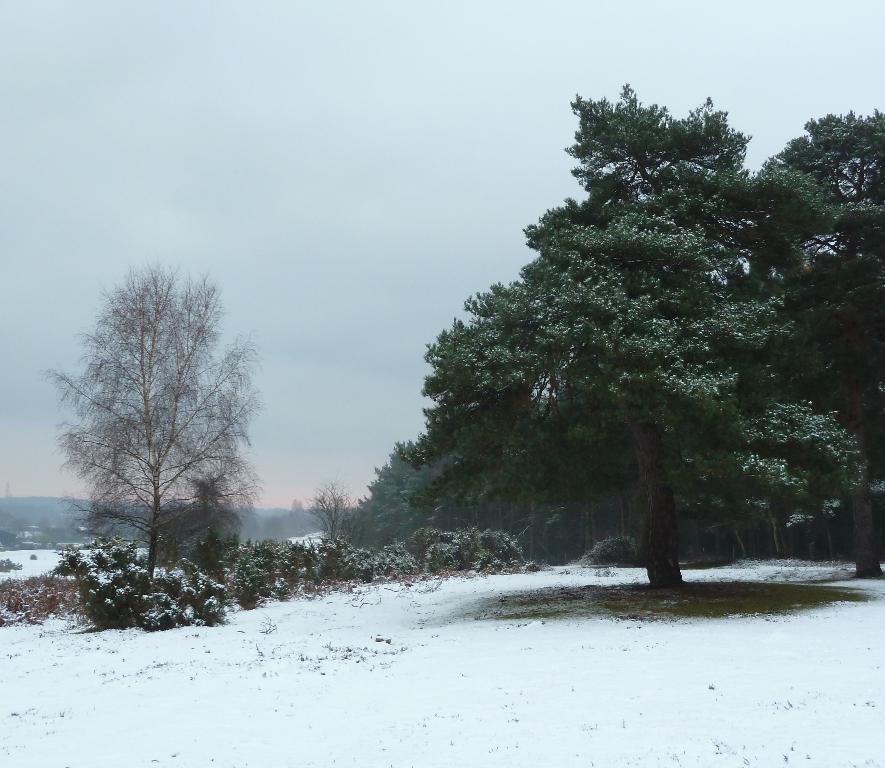What type of vegetation is present in the image? There are trees and plants in the image. What is covering the ground in the image? There is snow on the ground. What can be seen in the distance in the image? There are mountains visible in the background of the image. What is visible at the top of the image? The sky is visible at the top of the image. Can you tell me the route the dog takes to climb the mountain in the image? There is no dog present in the image, so it is not possible to determine a route for a dog to climb the mountain. 